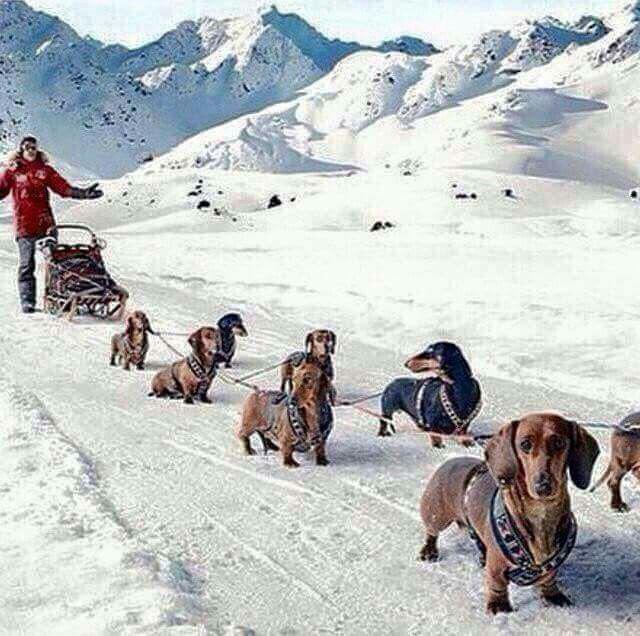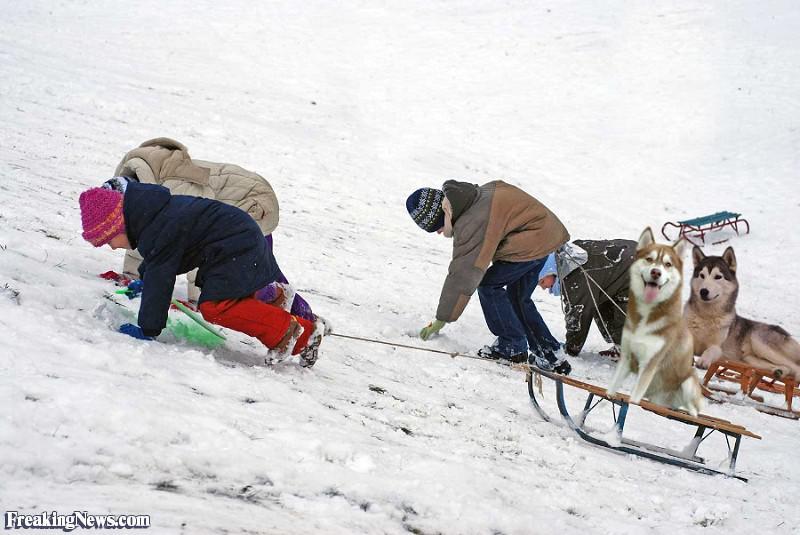The first image is the image on the left, the second image is the image on the right. Given the left and right images, does the statement "An image includes a child in a dark jacket leaning forward as he pulls a sled carrying one upright sitting husky on it across the snow." hold true? Answer yes or no. Yes. The first image is the image on the left, the second image is the image on the right. Considering the images on both sides, is "In the right image, there's at least one instance of a child pulling a dog on a sled." valid? Answer yes or no. Yes. 